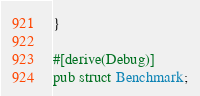Convert code to text. <code><loc_0><loc_0><loc_500><loc_500><_Rust_>}

#[derive(Debug)]
pub struct Benchmark;


</code> 